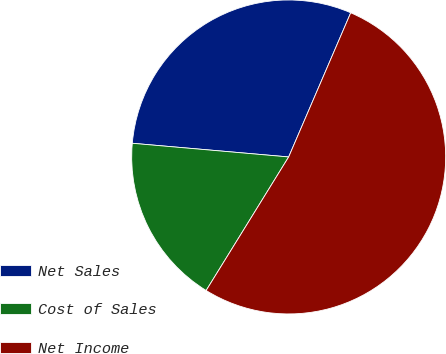Convert chart. <chart><loc_0><loc_0><loc_500><loc_500><pie_chart><fcel>Net Sales<fcel>Cost of Sales<fcel>Net Income<nl><fcel>30.08%<fcel>17.58%<fcel>52.34%<nl></chart> 